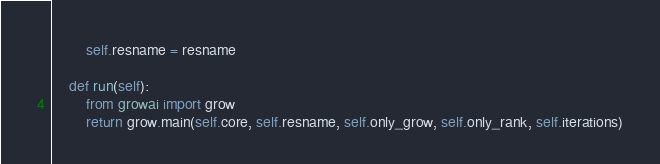<code> <loc_0><loc_0><loc_500><loc_500><_Python_>        self.resname = resname

    def run(self):
        from growai import grow
        return grow.main(self.core, self.resname, self.only_grow, self.only_rank, self.iterations)</code> 